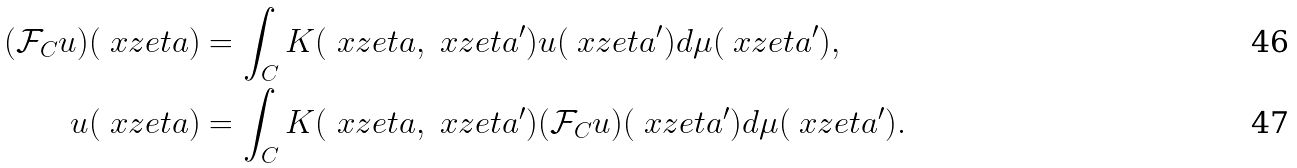<formula> <loc_0><loc_0><loc_500><loc_500>( \mathcal { F } _ { C } u ) ( \ x z e t a ) & = \int _ { C } K ( \ x z e t a , \ x z e t a ^ { \prime } ) u ( \ x z e t a ^ { \prime } ) d \mu ( \ x z e t a ^ { \prime } ) , \\ u ( \ x z e t a ) & = \int _ { C } K ( \ x z e t a , \ x z e t a ^ { \prime } ) ( \mathcal { F } _ { C } u ) ( \ x z e t a ^ { \prime } ) d \mu ( \ x z e t a ^ { \prime } ) .</formula> 